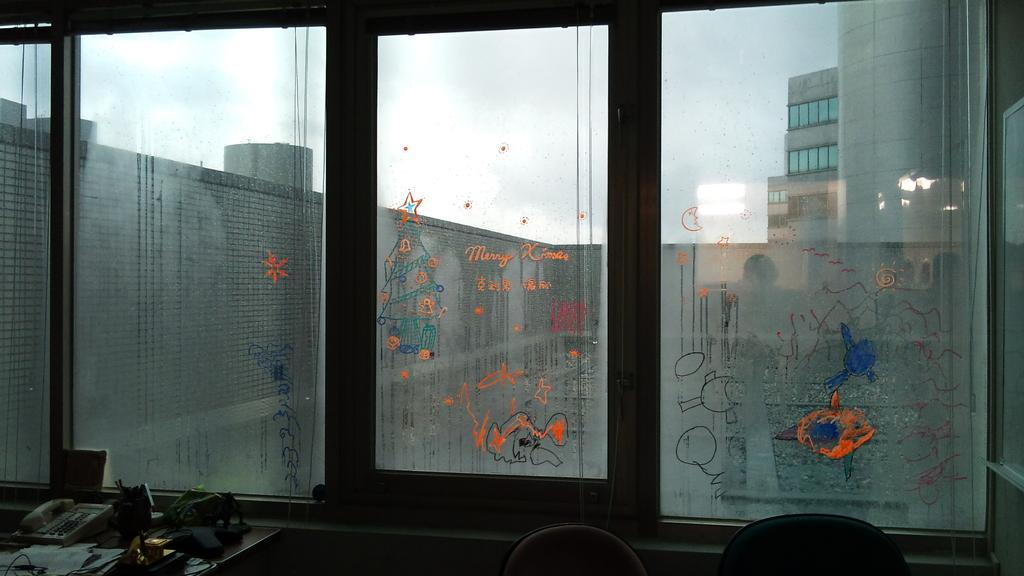What type of furniture is present in the image? There are chairs in the image. What communication device can be seen in the image? There is a telephone in the image. What type of material is present in the image? There are papers in the image. What piece of furniture is the telephone and papers placed on? There is a table in the image. What other objects are present in the image? There are objects in the image, but their specific nature is not mentioned in the facts. What type of windows are present in the image? There are glass windows with paintings in the image. What can be seen in the background of the image? There are buildings and sky visible in the background of the image. What is the weather like in the image? The presence of clouds in the sky suggests that it might be partly cloudy. What discovery was made in the image? There is no mention of a discovery in the image. --- Facts: 1. There is a person in the image. 12. The person is wearing a hat. 13. The person is holding a book. 14. There is a dog in the image. 15. The dog is sitting next to the person. 16. The person and the dog are in a park. 17. There are trees in the background of the image. 18. There is a pond in the background of the image. Absurd Topics: unicorn, flying saucer, magical wand Conversation: Who or what is present in the image? There is a person in the image. What is the person wearing on their head? The person is wearing a hat. What is the person holding in their hands? The person is holding a book. Who or what else is present in the image? There is a dog in the image. What is the dog doing in the image? The dog is sitting next to the person. Where are the person and the dog located in the image? The person and the dog are in a park. What can be seen in the background of the image? There are trees and a pond in the background of the image. Reasoning: Let's think step by step in order to produce the conversation. We start by identifying the main subjects and objects in the image based on the provided facts. We then formulate questions that focus on the location and characteristics of these subjects and objects, ensuring that each question can be answered definitively with the information given. We avoid yes/no questions and ensure that the language is simple and clear. Absurd Question/Answer: Can you see a unicorn in the image? There is no mention of a unicorn in the image. --- Facts: 11. There is a person in the image. 12. The person is holding a ball. 13. The person is wearing 